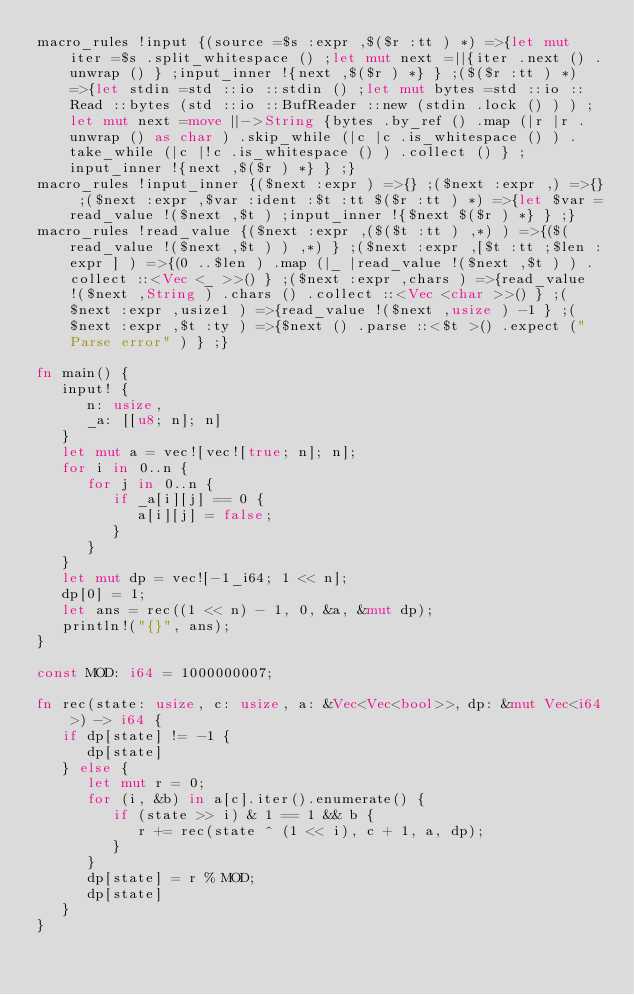<code> <loc_0><loc_0><loc_500><loc_500><_Rust_>macro_rules !input {(source =$s :expr ,$($r :tt ) *) =>{let mut iter =$s .split_whitespace () ;let mut next =||{iter .next () .unwrap () } ;input_inner !{next ,$($r ) *} } ;($($r :tt ) *) =>{let stdin =std ::io ::stdin () ;let mut bytes =std ::io ::Read ::bytes (std ::io ::BufReader ::new (stdin .lock () ) ) ;let mut next =move ||->String {bytes .by_ref () .map (|r |r .unwrap () as char ) .skip_while (|c |c .is_whitespace () ) .take_while (|c |!c .is_whitespace () ) .collect () } ;input_inner !{next ,$($r ) *} } ;}
macro_rules !input_inner {($next :expr ) =>{} ;($next :expr ,) =>{} ;($next :expr ,$var :ident :$t :tt $($r :tt ) *) =>{let $var =read_value !($next ,$t ) ;input_inner !{$next $($r ) *} } ;}
macro_rules !read_value {($next :expr ,($($t :tt ) ,*) ) =>{($(read_value !($next ,$t ) ) ,*) } ;($next :expr ,[$t :tt ;$len :expr ] ) =>{(0 ..$len ) .map (|_ |read_value !($next ,$t ) ) .collect ::<Vec <_ >>() } ;($next :expr ,chars ) =>{read_value !($next ,String ) .chars () .collect ::<Vec <char >>() } ;($next :expr ,usize1 ) =>{read_value !($next ,usize ) -1 } ;($next :expr ,$t :ty ) =>{$next () .parse ::<$t >() .expect ("Parse error" ) } ;}

fn main() {
   input! {
      n: usize,
      _a: [[u8; n]; n]
   }
   let mut a = vec![vec![true; n]; n];
   for i in 0..n {
      for j in 0..n {
         if _a[i][j] == 0 {
            a[i][j] = false;
         }
      }
   }
   let mut dp = vec![-1_i64; 1 << n];
   dp[0] = 1;
   let ans = rec((1 << n) - 1, 0, &a, &mut dp);
   println!("{}", ans);
}

const MOD: i64 = 1000000007;

fn rec(state: usize, c: usize, a: &Vec<Vec<bool>>, dp: &mut Vec<i64>) -> i64 {
   if dp[state] != -1 {
      dp[state]
   } else {
      let mut r = 0;
      for (i, &b) in a[c].iter().enumerate() {
         if (state >> i) & 1 == 1 && b {
            r += rec(state ^ (1 << i), c + 1, a, dp);
         }
      }
      dp[state] = r % MOD;
      dp[state]
   }
}
</code> 